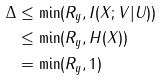Convert formula to latex. <formula><loc_0><loc_0><loc_500><loc_500>\Delta & \leq \min ( R _ { y } , I ( X ; V | U ) ) \\ & \leq \min ( R _ { y } , H ( X ) ) \\ & = \min ( R _ { y } , 1 )</formula> 